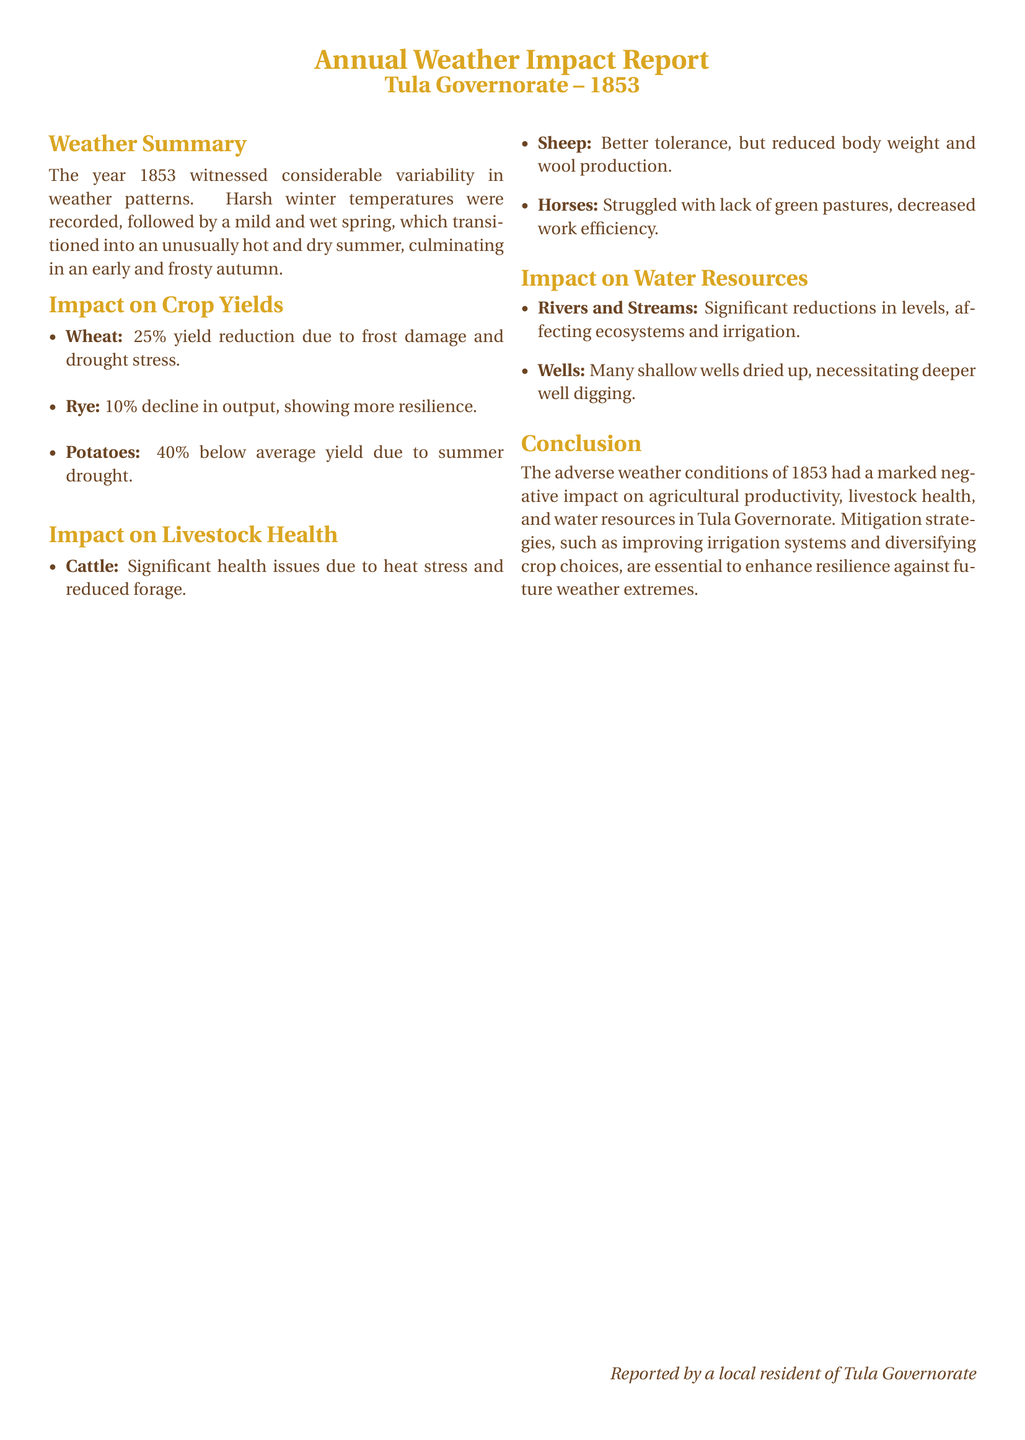What was the weather pattern in 1853? The report states that the year was characterized by considerable variability, including harsh winter temperatures, mild and wet spring, hot and dry summer, and an early frosty autumn.
Answer: variability What was the yield reduction percentage for wheat? The document indicates a 25% yield reduction for wheat due to frost damage and drought stress.
Answer: 25% How did sheep fare in terms of health? The report mentions that sheep had better tolerance but experienced reduced body weight and wool production.
Answer: reduced body weight and wool production What was the impact on rivers and streams? The document notes significant reductions in levels of rivers and streams, which affected ecosystems and irrigation.
Answer: significant reductions Which crop had the lowest yield in 1853? According to the report, potatoes had a 40% below average yield due to summer drought, which is the lowest.
Answer: potatoes What health issues did cattle face? The report specifies that cattle experienced significant health issues due to heat stress and reduced forage.
Answer: heat stress and reduced forage What year does the report cover? The document clearly identifies that it covers the year 1853.
Answer: 1853 What is suggested as a mitigation strategy? The report suggests improving irrigation systems and diversifying crop choices as essential mitigation strategies.
Answer: improving irrigation systems and diversifying crop choices 